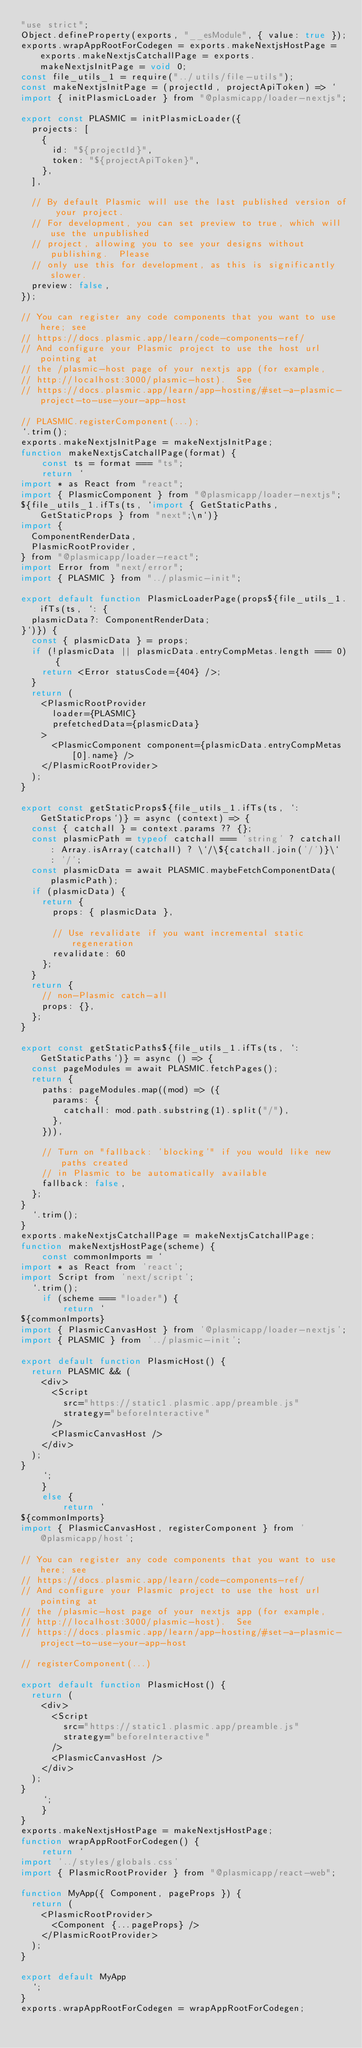Convert code to text. <code><loc_0><loc_0><loc_500><loc_500><_JavaScript_>"use strict";
Object.defineProperty(exports, "__esModule", { value: true });
exports.wrapAppRootForCodegen = exports.makeNextjsHostPage = exports.makeNextjsCatchallPage = exports.makeNextjsInitPage = void 0;
const file_utils_1 = require("../utils/file-utils");
const makeNextjsInitPage = (projectId, projectApiToken) => `
import { initPlasmicLoader } from "@plasmicapp/loader-nextjs";

export const PLASMIC = initPlasmicLoader({
  projects: [
    {
      id: "${projectId}",
      token: "${projectApiToken}",
    },
  ],

  // By default Plasmic will use the last published version of your project.
  // For development, you can set preview to true, which will use the unpublished
  // project, allowing you to see your designs without publishing.  Please
  // only use this for development, as this is significantly slower.
  preview: false,
});

// You can register any code components that you want to use here; see
// https://docs.plasmic.app/learn/code-components-ref/
// And configure your Plasmic project to use the host url pointing at
// the /plasmic-host page of your nextjs app (for example,
// http://localhost:3000/plasmic-host).  See
// https://docs.plasmic.app/learn/app-hosting/#set-a-plasmic-project-to-use-your-app-host

// PLASMIC.registerComponent(...);
`.trim();
exports.makeNextjsInitPage = makeNextjsInitPage;
function makeNextjsCatchallPage(format) {
    const ts = format === "ts";
    return `
import * as React from "react";
import { PlasmicComponent } from "@plasmicapp/loader-nextjs";
${file_utils_1.ifTs(ts, `import { GetStaticPaths, GetStaticProps } from "next";\n`)}
import {
  ComponentRenderData,
  PlasmicRootProvider,
} from "@plasmicapp/loader-react";
import Error from "next/error";
import { PLASMIC } from "../plasmic-init";

export default function PlasmicLoaderPage(props${file_utils_1.ifTs(ts, `: {
  plasmicData?: ComponentRenderData;
}`)}) {
  const { plasmicData } = props;
  if (!plasmicData || plasmicData.entryCompMetas.length === 0) {
    return <Error statusCode={404} />;
  }
  return (
    <PlasmicRootProvider
      loader={PLASMIC}
      prefetchedData={plasmicData}
    >
      <PlasmicComponent component={plasmicData.entryCompMetas[0].name} />
    </PlasmicRootProvider>
  );
}

export const getStaticProps${file_utils_1.ifTs(ts, `: GetStaticProps`)} = async (context) => {
  const { catchall } = context.params ?? {};
  const plasmicPath = typeof catchall === 'string' ? catchall : Array.isArray(catchall) ? \`/\${catchall.join('/')}\` : '/';
  const plasmicData = await PLASMIC.maybeFetchComponentData(plasmicPath);
  if (plasmicData) {
    return {
      props: { plasmicData },

      // Use revalidate if you want incremental static regeneration
      revalidate: 60
    };
  }
  return {
    // non-Plasmic catch-all
    props: {},
  };
}

export const getStaticPaths${file_utils_1.ifTs(ts, `: GetStaticPaths`)} = async () => {
  const pageModules = await PLASMIC.fetchPages();
  return {
    paths: pageModules.map((mod) => ({
      params: {
        catchall: mod.path.substring(1).split("/"),
      },
    })),

    // Turn on "fallback: 'blocking'" if you would like new paths created
    // in Plasmic to be automatically available
    fallback: false,
  };
}
  `.trim();
}
exports.makeNextjsCatchallPage = makeNextjsCatchallPage;
function makeNextjsHostPage(scheme) {
    const commonImports = `
import * as React from 'react';
import Script from 'next/script';
  `.trim();
    if (scheme === "loader") {
        return `
${commonImports}
import { PlasmicCanvasHost } from '@plasmicapp/loader-nextjs';
import { PLASMIC } from '../plasmic-init';

export default function PlasmicHost() {
  return PLASMIC && (
    <div>
      <Script
        src="https://static1.plasmic.app/preamble.js"
        strategy="beforeInteractive"
      />
      <PlasmicCanvasHost />
    </div>
  );
}
    `;
    }
    else {
        return `
${commonImports}
import { PlasmicCanvasHost, registerComponent } from '@plasmicapp/host';

// You can register any code components that you want to use here; see
// https://docs.plasmic.app/learn/code-components-ref/
// And configure your Plasmic project to use the host url pointing at
// the /plasmic-host page of your nextjs app (for example,
// http://localhost:3000/plasmic-host).  See
// https://docs.plasmic.app/learn/app-hosting/#set-a-plasmic-project-to-use-your-app-host

// registerComponent(...)

export default function PlasmicHost() {
  return (
    <div>
      <Script
        src="https://static1.plasmic.app/preamble.js"
        strategy="beforeInteractive"
      />
      <PlasmicCanvasHost />
    </div>
  );
}
    `;
    }
}
exports.makeNextjsHostPage = makeNextjsHostPage;
function wrapAppRootForCodegen() {
    return `
import '../styles/globals.css'
import { PlasmicRootProvider } from "@plasmicapp/react-web";

function MyApp({ Component, pageProps }) {
  return (
    <PlasmicRootProvider>
      <Component {...pageProps} />
    </PlasmicRootProvider>
  );
}

export default MyApp
  `;
}
exports.wrapAppRootForCodegen = wrapAppRootForCodegen;
</code> 